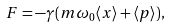Convert formula to latex. <formula><loc_0><loc_0><loc_500><loc_500>F = - \gamma ( m \omega _ { 0 } \langle x \rangle + \langle p \rangle ) ,</formula> 